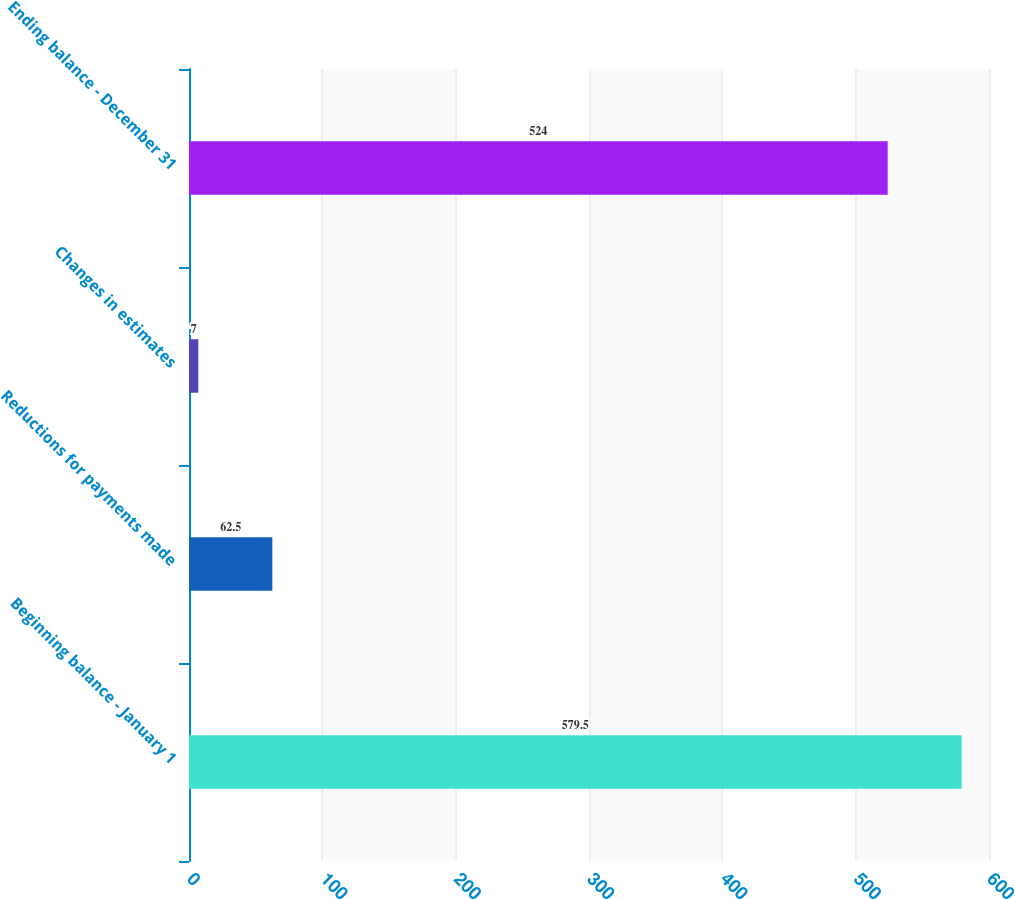Convert chart. <chart><loc_0><loc_0><loc_500><loc_500><bar_chart><fcel>Beginning balance - January 1<fcel>Reductions for payments made<fcel>Changes in estimates<fcel>Ending balance - December 31<nl><fcel>579.5<fcel>62.5<fcel>7<fcel>524<nl></chart> 